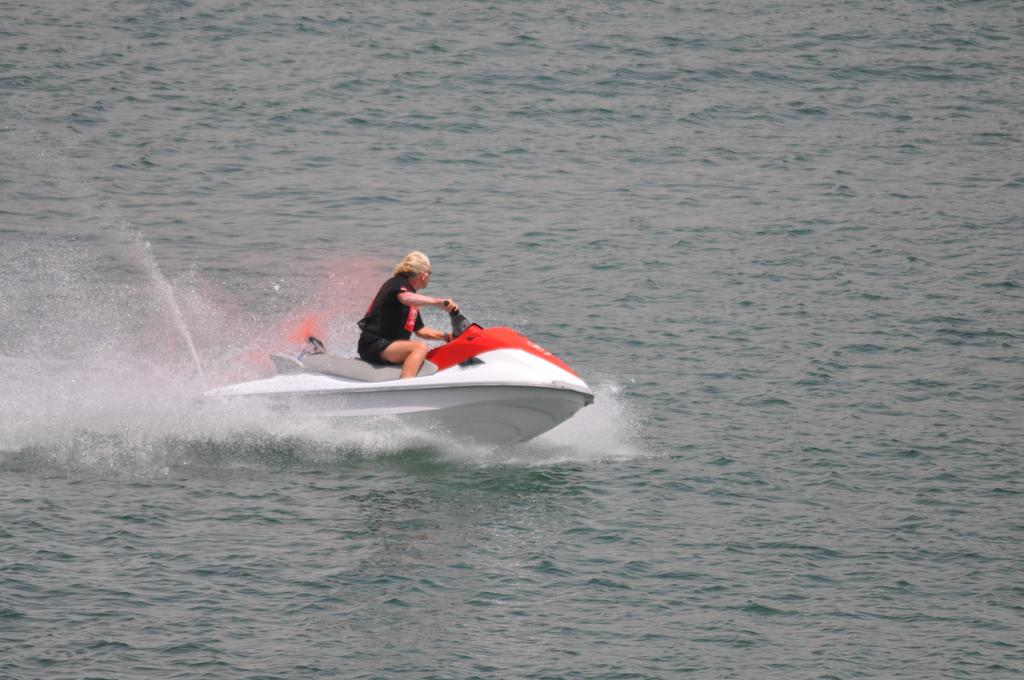Who is the main subject in the image? There is a man in the image. What is the man doing in the image? The man is riding a speedboat. Where is the speedboat located? The speedboat is on the water. What can be seen in the background of the image? There is water visible in the image. What type of statement can be seen written on the side of the speedboat? There is no statement visible on the side of the speedboat in the image. What type of soda is the man holding while riding the speedboat? The man is not holding any soda in the image. Can you see any scissors in the image? There are no scissors present in the image. 